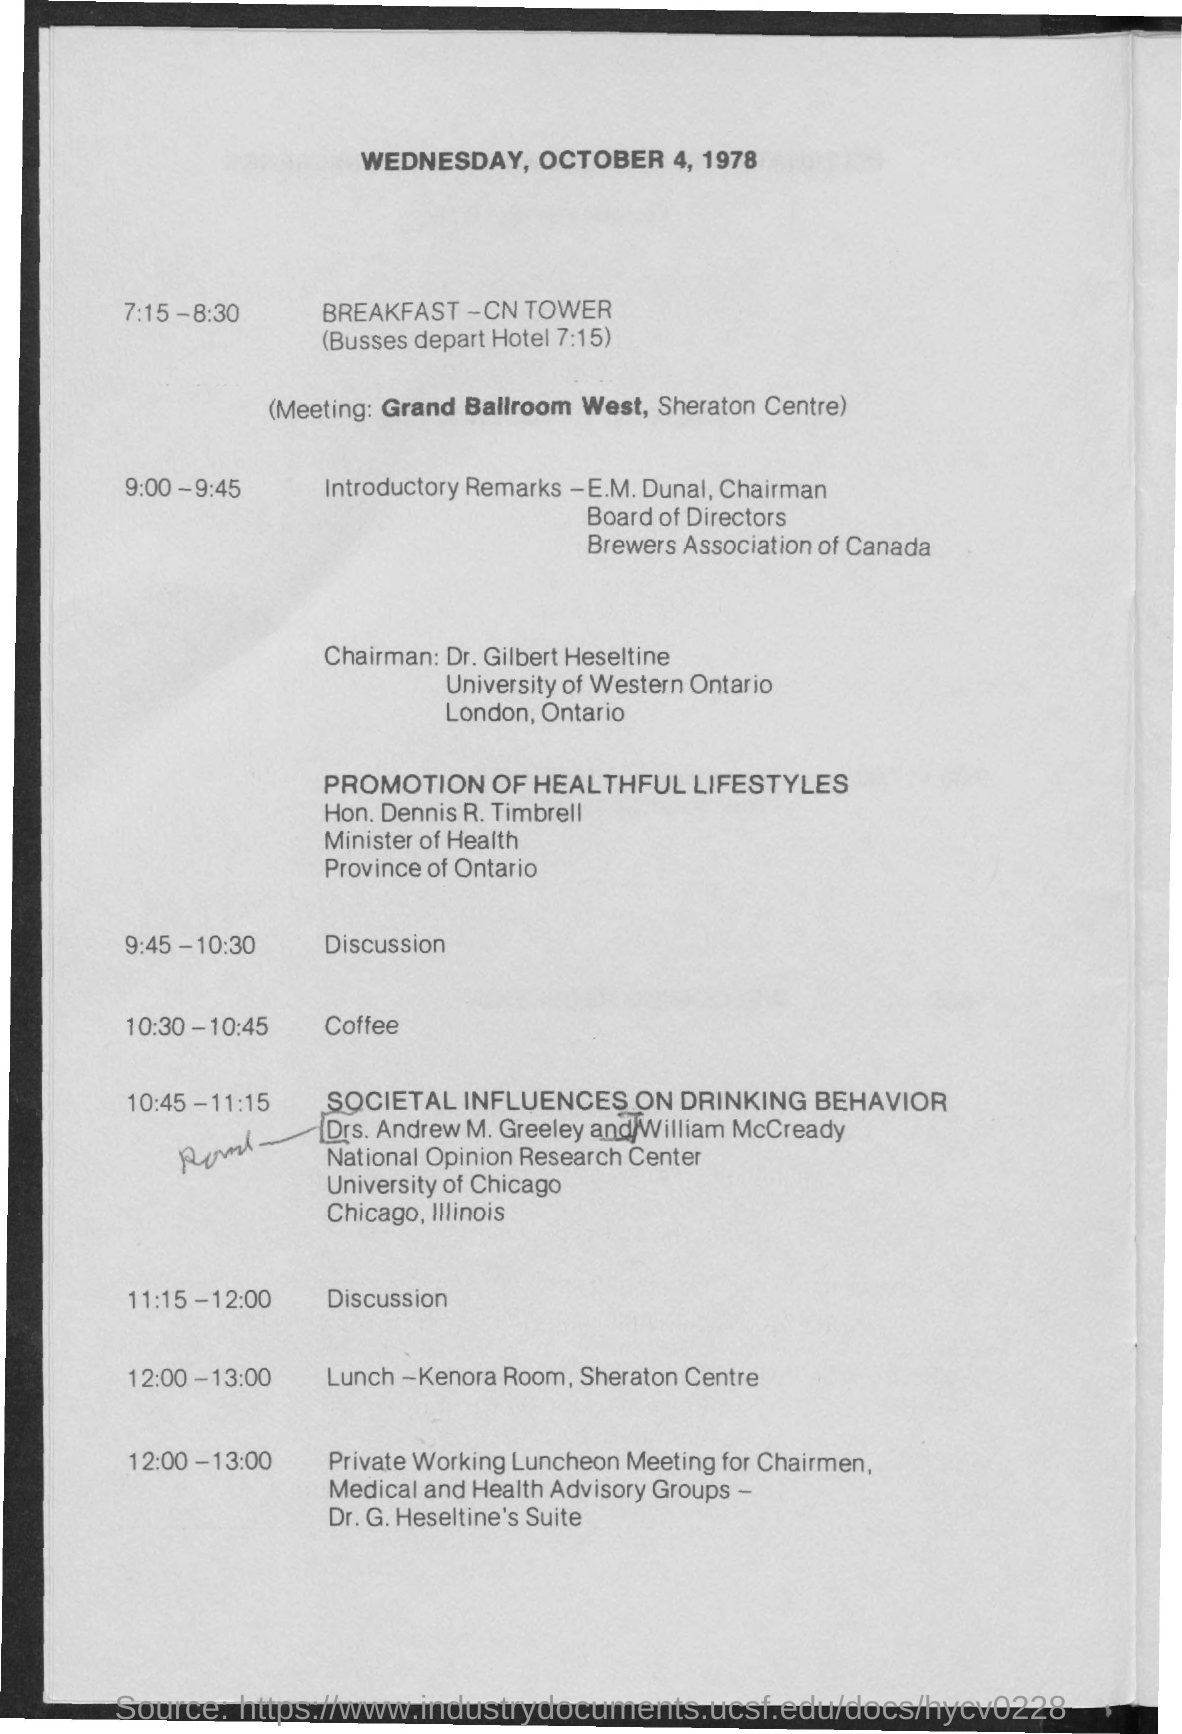List a handful of essential elements in this visual. The schedule at 10:30 - 10:45 is unknown. At the time of 9:45 - 10:30, the discussion is scheduled. The meeting is scheduled to take place in the Grand Ballroom West. At the time of 11:15-12:00, a discussion is taking place. At the time of 12:00-13:00, lunch is scheduled. 